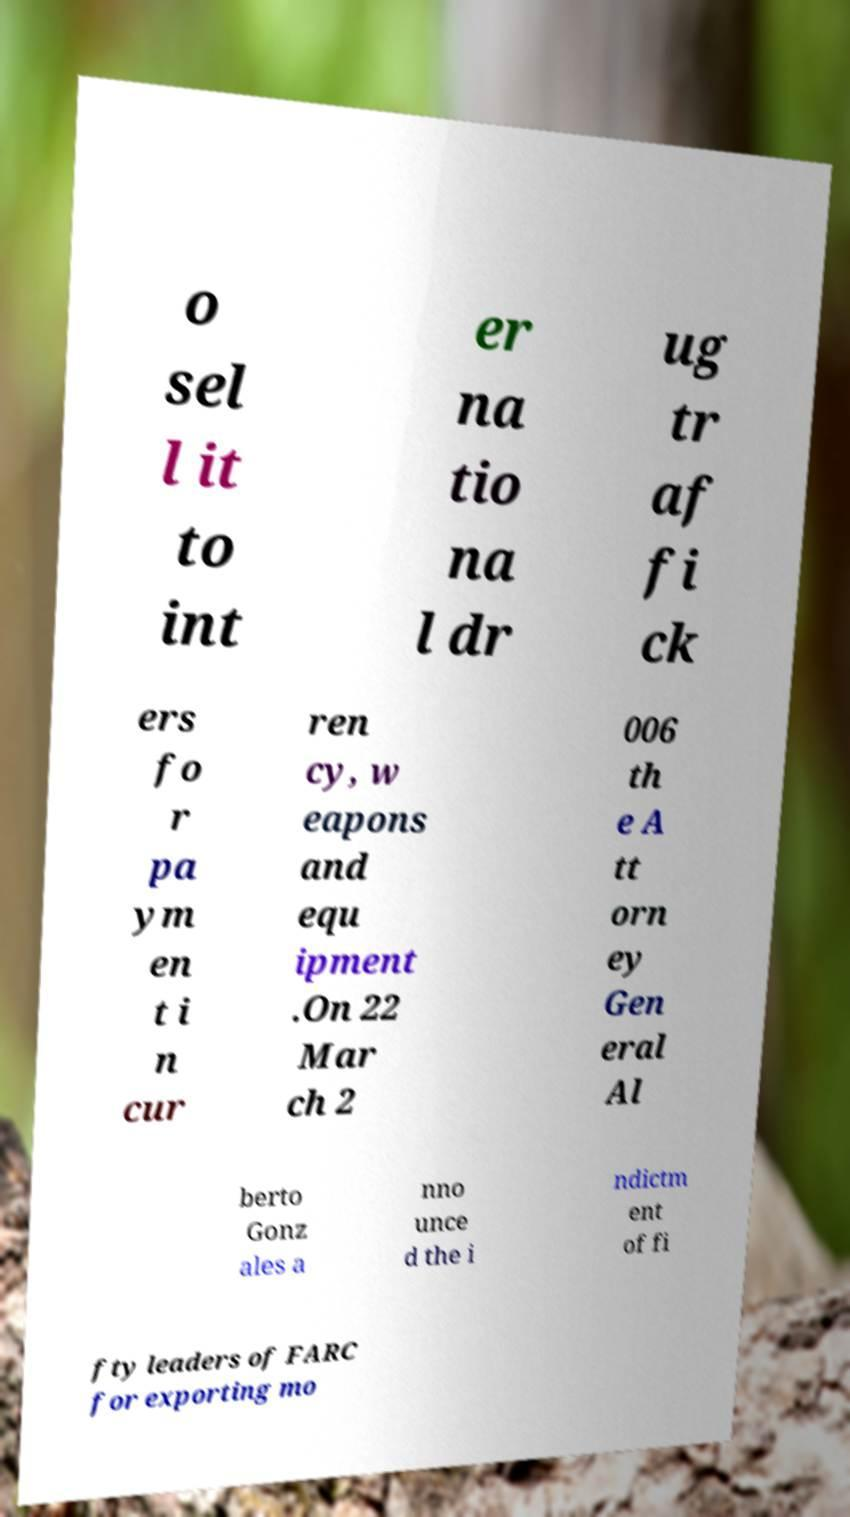Please read and relay the text visible in this image. What does it say? o sel l it to int er na tio na l dr ug tr af fi ck ers fo r pa ym en t i n cur ren cy, w eapons and equ ipment .On 22 Mar ch 2 006 th e A tt orn ey Gen eral Al berto Gonz ales a nno unce d the i ndictm ent of fi fty leaders of FARC for exporting mo 